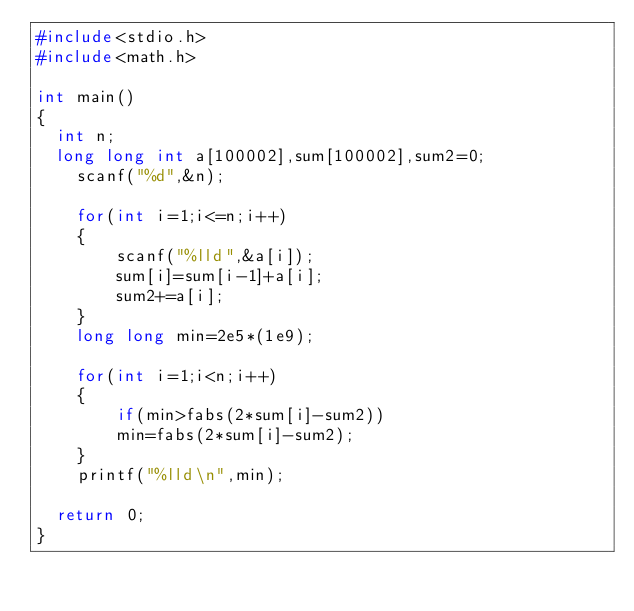Convert code to text. <code><loc_0><loc_0><loc_500><loc_500><_C_>#include<stdio.h>
#include<math.h>

int main()
{	
	int n;
	long long int a[100002],sum[100002],sum2=0;
    scanf("%d",&n);
    
    for(int i=1;i<=n;i++)
    {
        scanf("%lld",&a[i]);
        sum[i]=sum[i-1]+a[i];
        sum2+=a[i];
    }
    long long min=2e5*(1e9);
    
    for(int i=1;i<n;i++)
    {
        if(min>fabs(2*sum[i]-sum2))
        min=fabs(2*sum[i]-sum2);
    }
    printf("%lld\n",min);
	
	return 0;
}</code> 